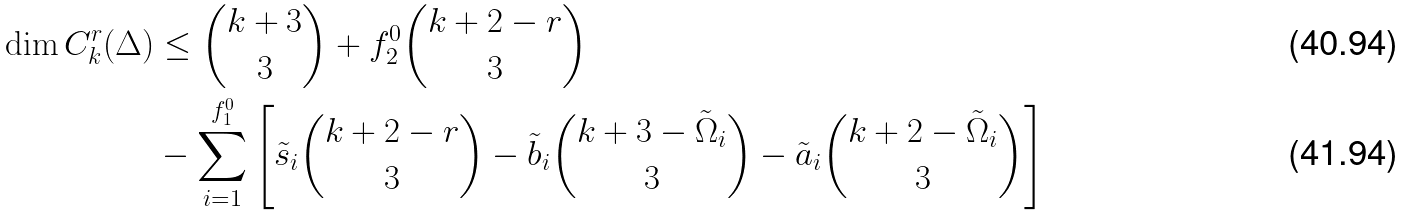Convert formula to latex. <formula><loc_0><loc_0><loc_500><loc_500>\dim C _ { k } ^ { r } ( \Delta ) & \leq \binom { k + 3 } { 3 } + f _ { 2 } ^ { 0 } \binom { k + 2 - r } { 3 } \\ & - \sum _ { i = 1 } ^ { f _ { 1 } ^ { 0 } } \left [ \tilde { s } _ { i } \binom { k + 2 - r } { 3 } - \tilde { b } _ { i } \binom { k + 3 - \tilde { \Omega } _ { i } } { 3 } - \tilde { a } _ { i } \binom { k + 2 - \tilde { \Omega } _ { i } } { 3 } \right ]</formula> 